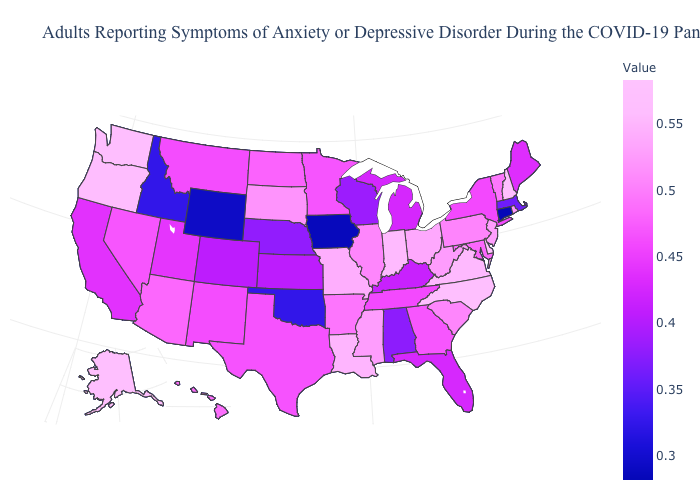Does Wyoming have the lowest value in the West?
Keep it brief. Yes. Does New Mexico have the highest value in the USA?
Answer briefly. No. Among the states that border Alabama , which have the highest value?
Write a very short answer. Mississippi. Which states hav the highest value in the South?
Quick response, please. Delaware. Among the states that border Rhode Island , which have the lowest value?
Answer briefly. Connecticut. Does Indiana have the highest value in the MidWest?
Answer briefly. Yes. Does Montana have the highest value in the West?
Give a very brief answer. No. 